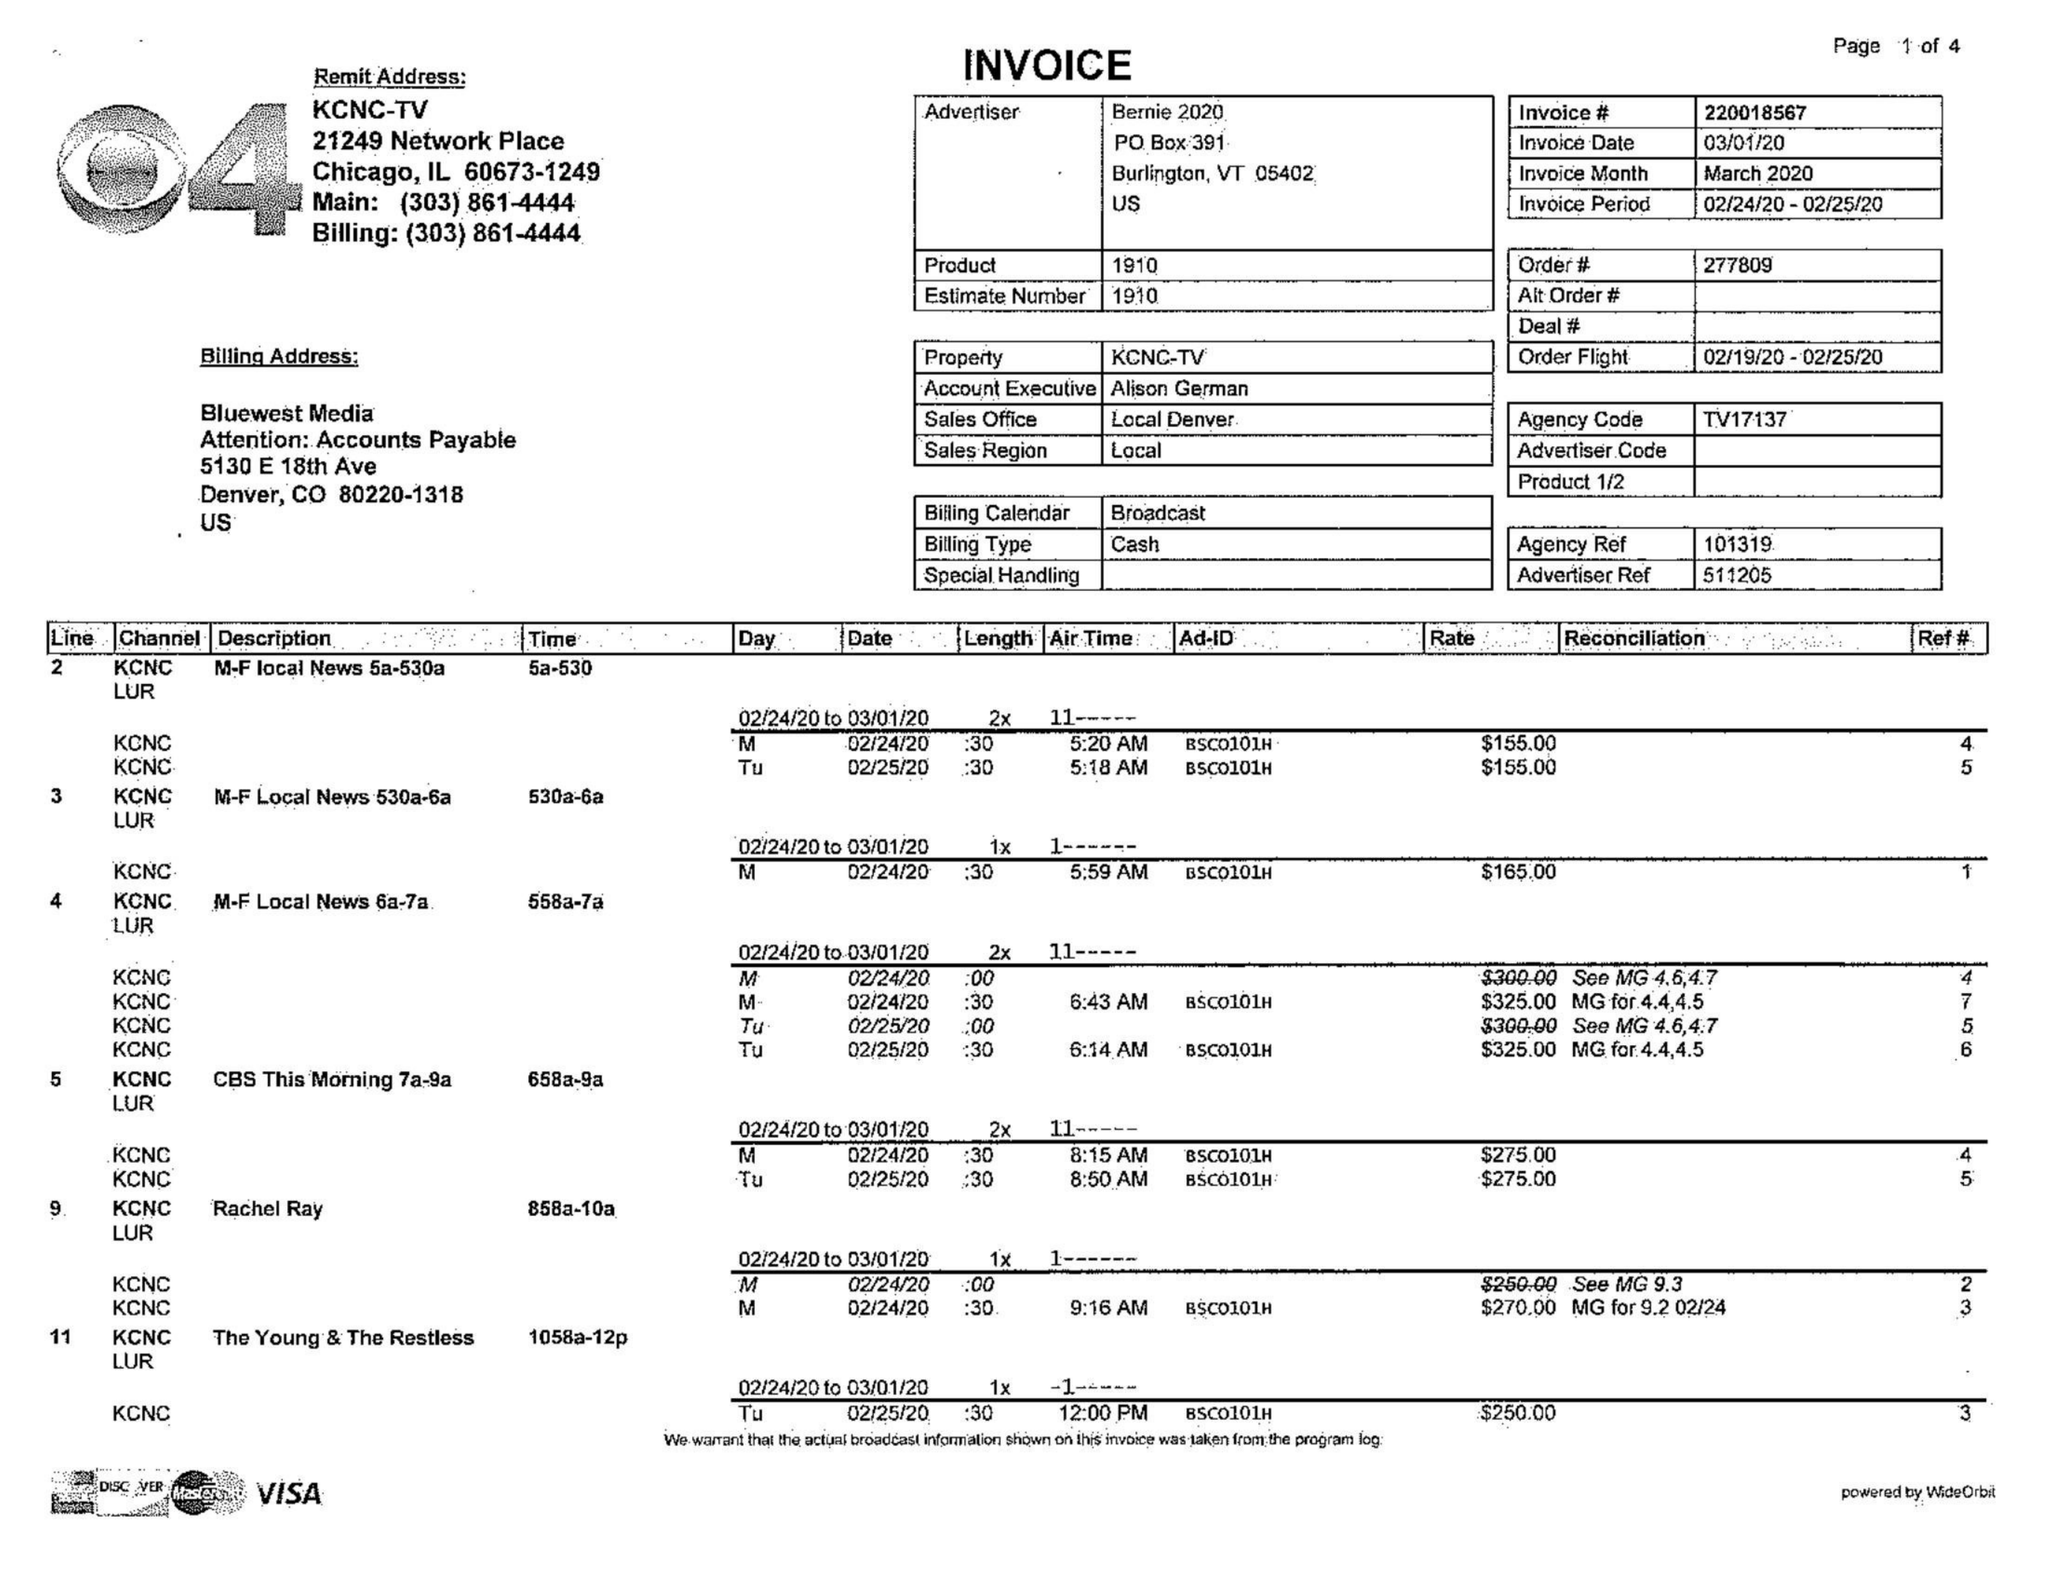What is the value for the gross_amount?
Answer the question using a single word or phrase. 10910.00 